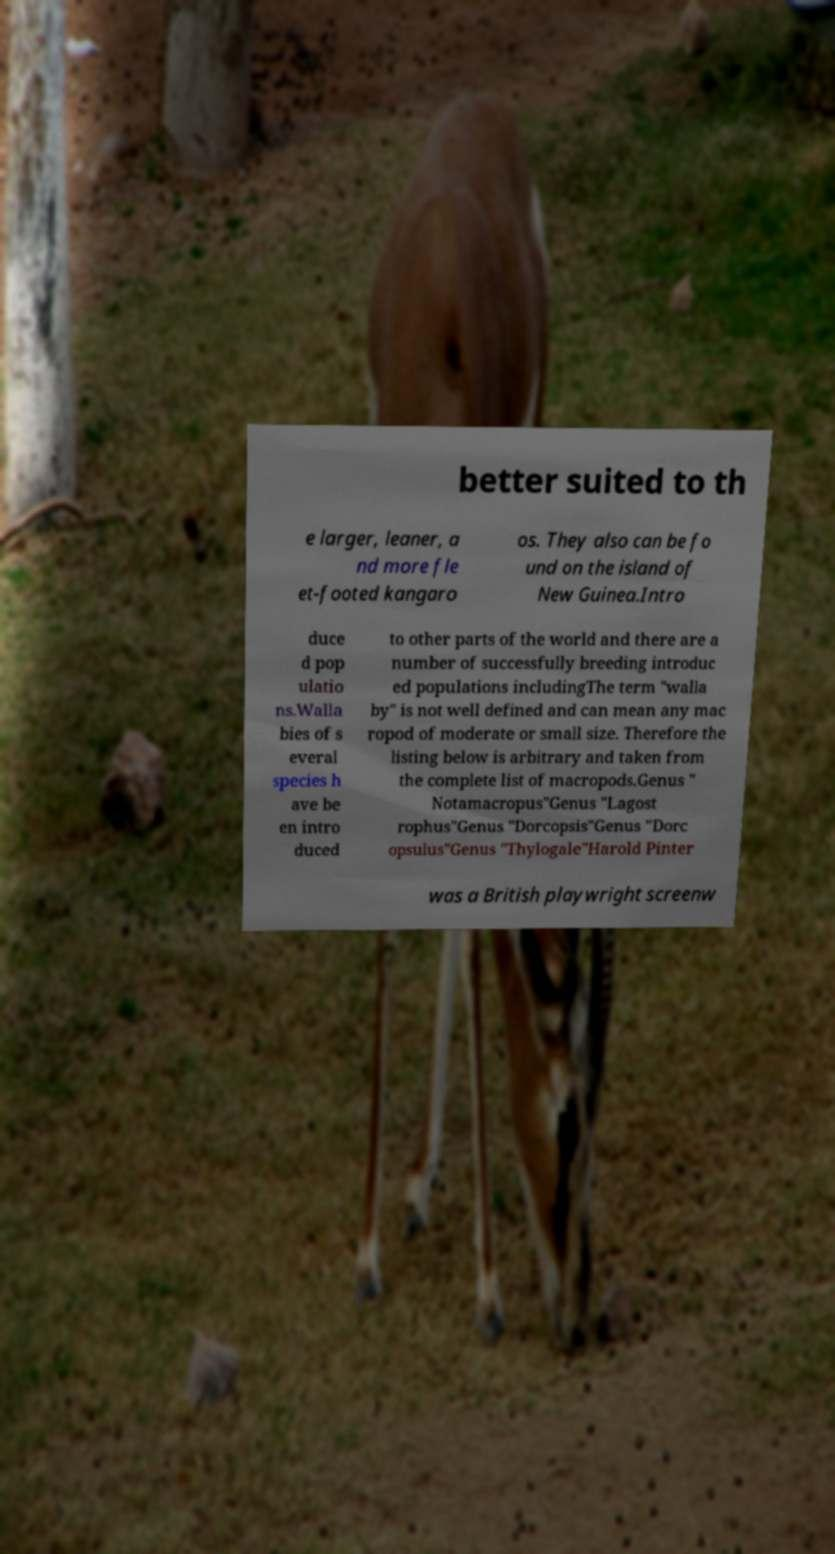Could you extract and type out the text from this image? better suited to th e larger, leaner, a nd more fle et-footed kangaro os. They also can be fo und on the island of New Guinea.Intro duce d pop ulatio ns.Walla bies of s everal species h ave be en intro duced to other parts of the world and there are a number of successfully breeding introduc ed populations includingThe term "walla by" is not well defined and can mean any mac ropod of moderate or small size. Therefore the listing below is arbitrary and taken from the complete list of macropods.Genus " Notamacropus"Genus "Lagost rophus"Genus "Dorcopsis"Genus "Dorc opsulus"Genus "Thylogale"Harold Pinter was a British playwright screenw 